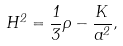Convert formula to latex. <formula><loc_0><loc_0><loc_500><loc_500>H ^ { 2 } = \frac { 1 } { 3 } \rho - \frac { K } { a ^ { 2 } } ,</formula> 